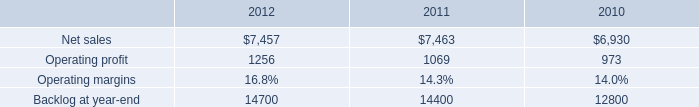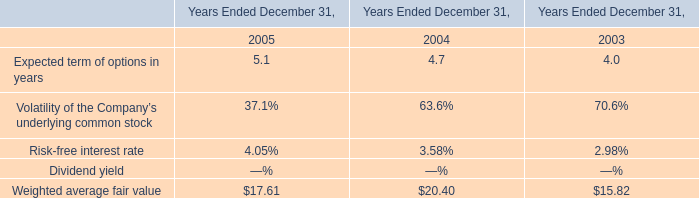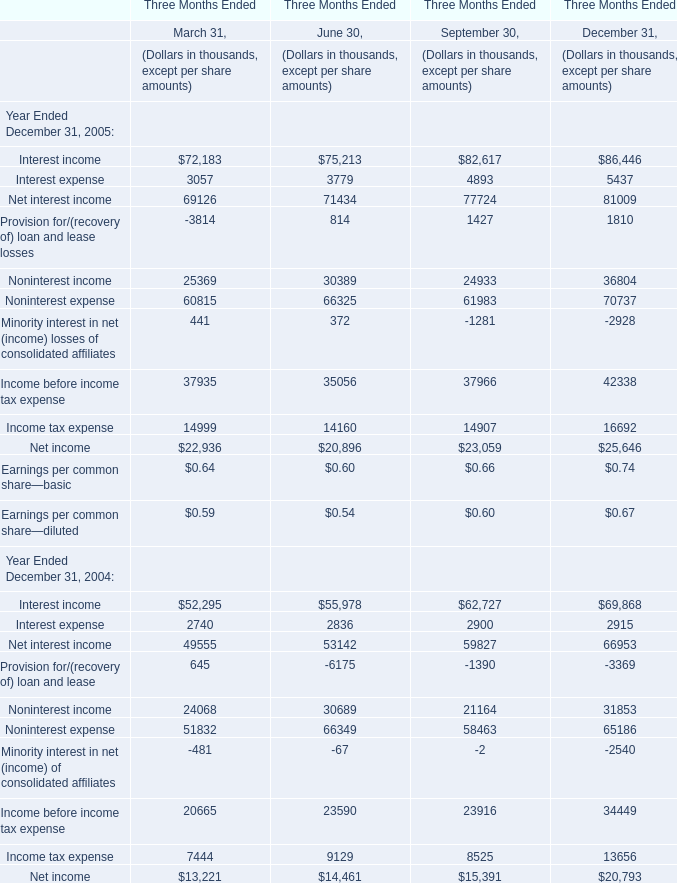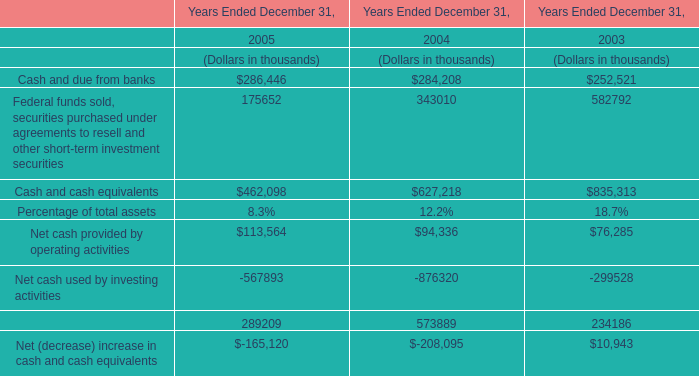In the year with lowest amount of Cash and cash equivalents in Table 3, what's the increasing rate of Weighted average fair value in Table 1? 
Computations: ((17.61 - 20.4) / 20.4)
Answer: -0.13676. 